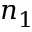<formula> <loc_0><loc_0><loc_500><loc_500>n _ { 1 }</formula> 